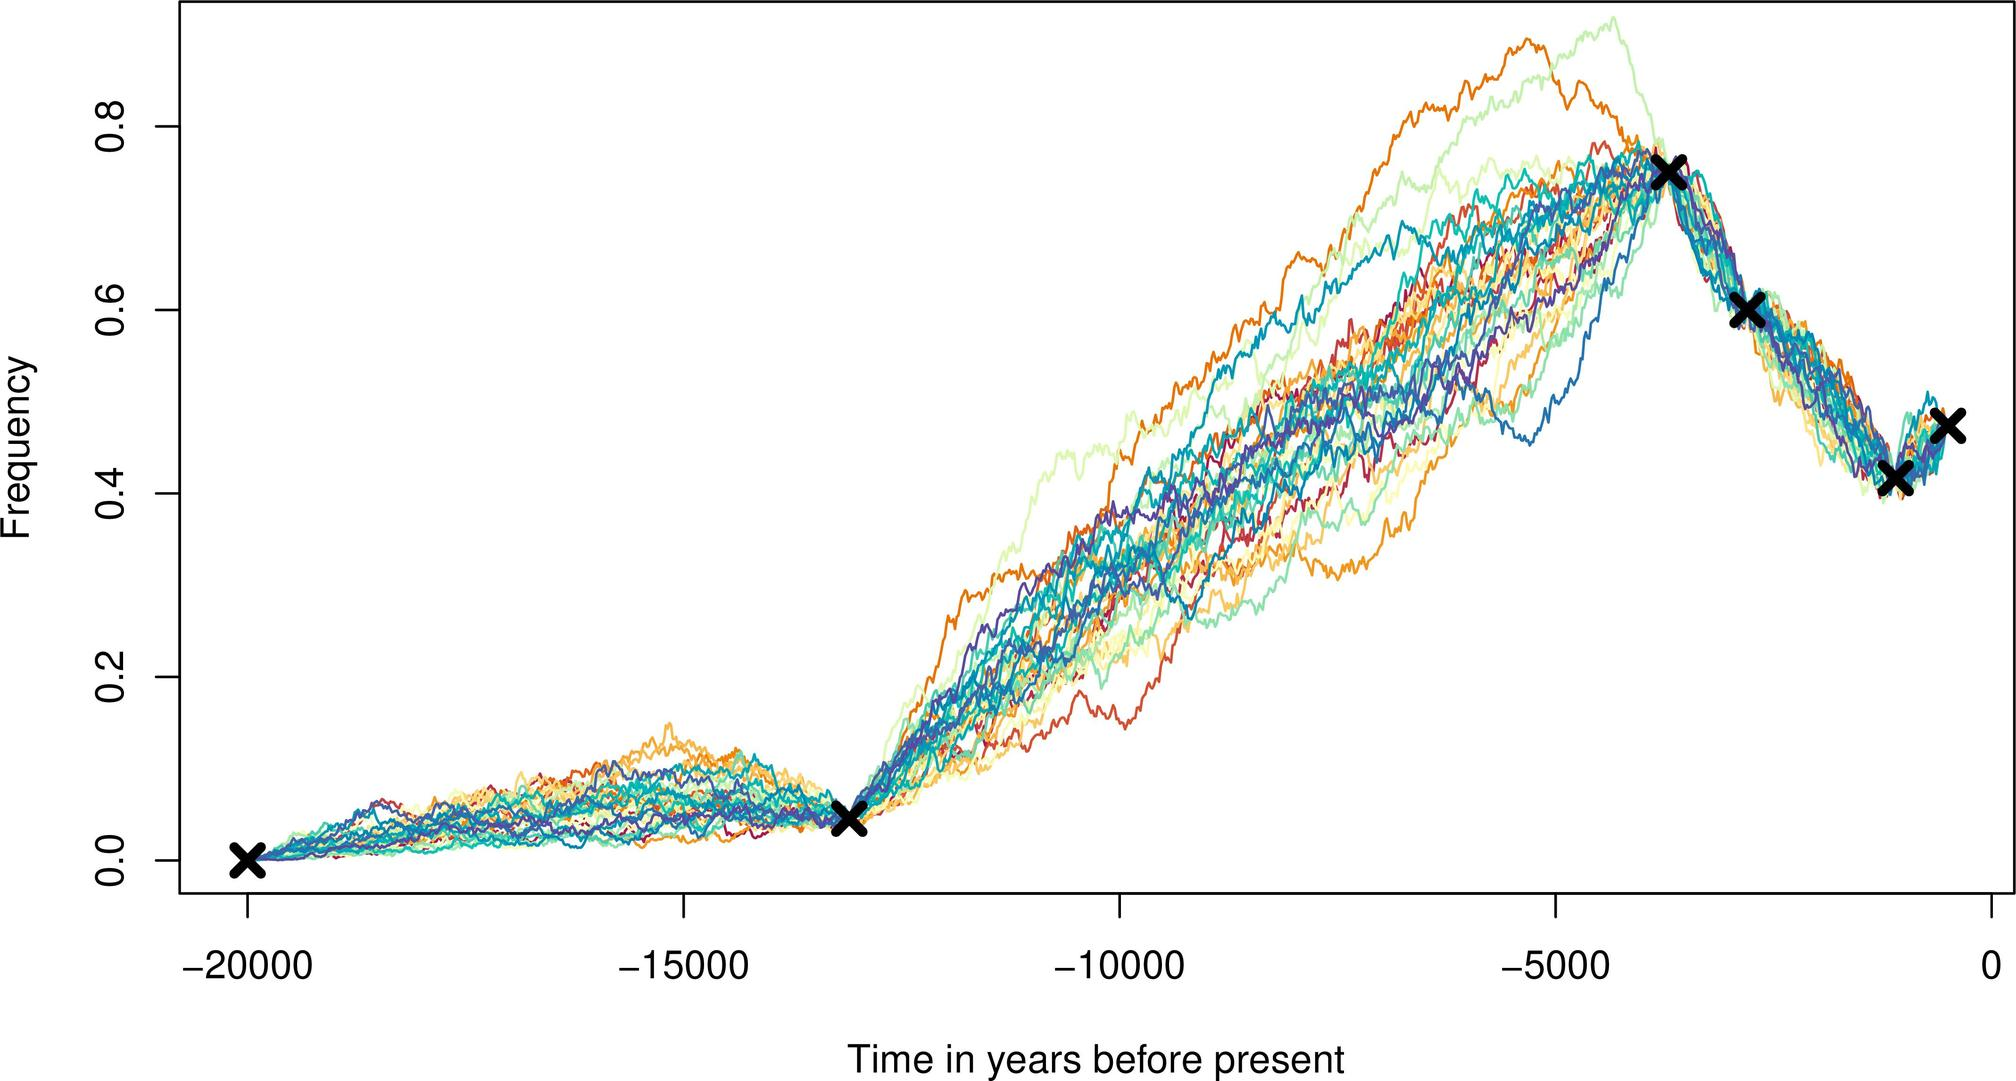Can you explain what might cause such close clustering in scientific data? Clusters in scientific data often indicate a strong common signal shared among the measurements. This could be due to a number of factors such as a widespread environmental event, societal patterns, or a shared cause-effect relationship prevalent during the time in question. The observed clustering suggests that the event was significant in scale to be detected across various instances or samples.  Given the time scale, could this graph be related to climate data? Yes, given the extensive time scale of tens of thousands of years, it's plausible that the graph could represent climate data, such as temperature or CO2 measurements. Such long-term records are often pulled from ice cores, sediment layers, or tree rings, which can reflect climate conditions and changes over millennia. 